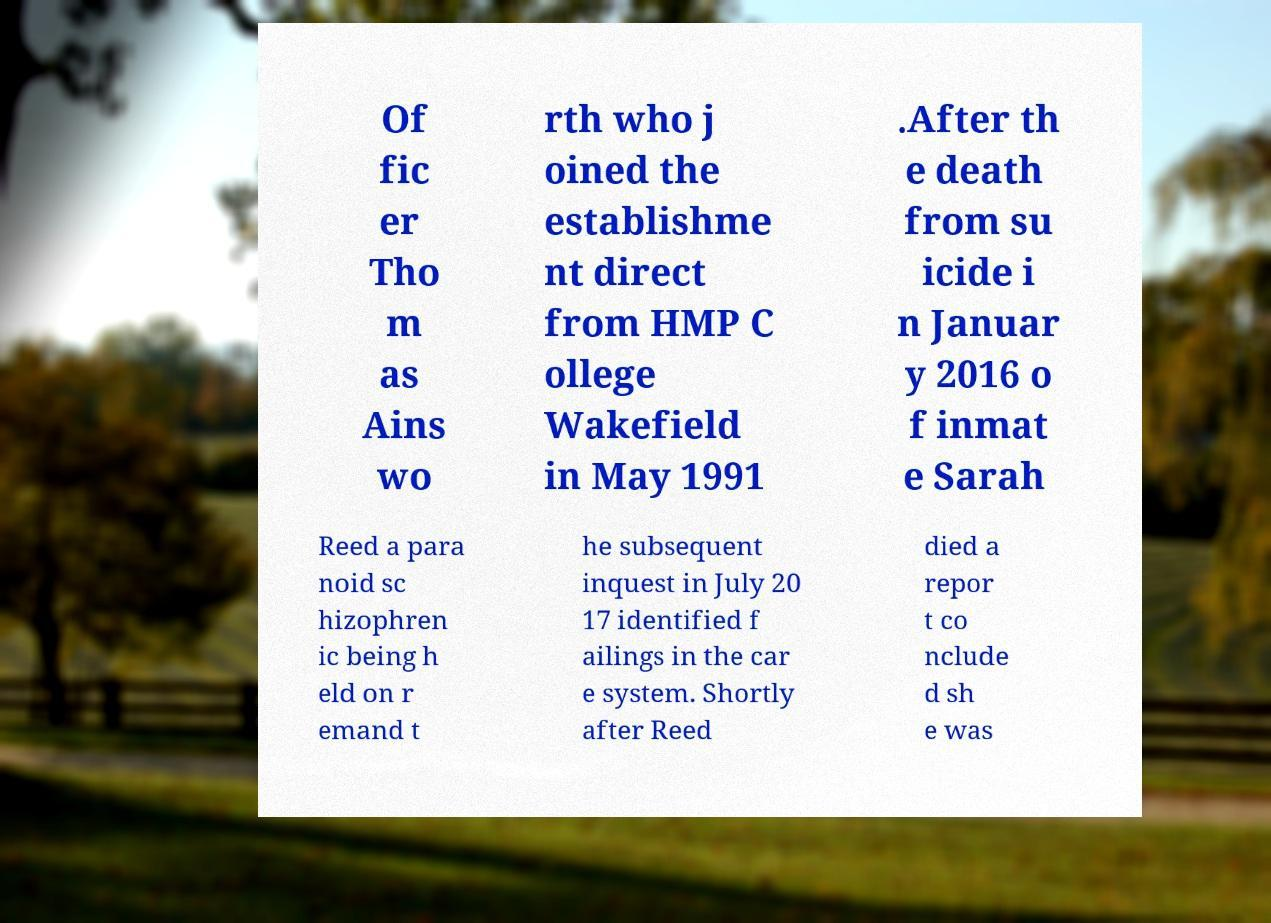Could you extract and type out the text from this image? Of fic er Tho m as Ains wo rth who j oined the establishme nt direct from HMP C ollege Wakefield in May 1991 .After th e death from su icide i n Januar y 2016 o f inmat e Sarah Reed a para noid sc hizophren ic being h eld on r emand t he subsequent inquest in July 20 17 identified f ailings in the car e system. Shortly after Reed died a repor t co nclude d sh e was 